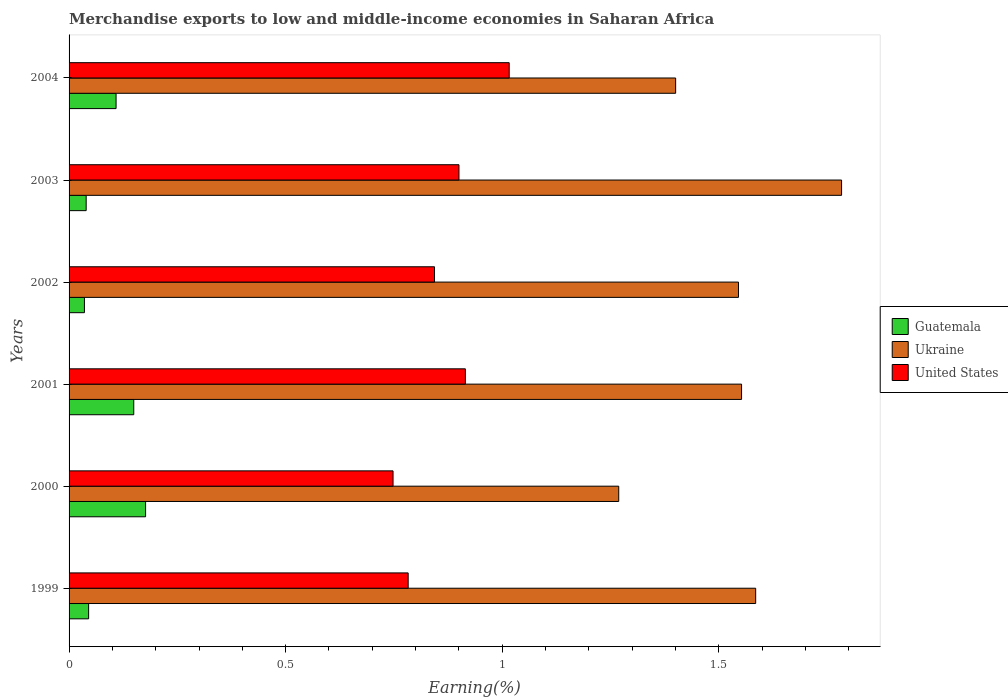How many bars are there on the 5th tick from the top?
Provide a short and direct response. 3. How many bars are there on the 3rd tick from the bottom?
Make the answer very short. 3. What is the label of the 6th group of bars from the top?
Your response must be concise. 1999. In how many cases, is the number of bars for a given year not equal to the number of legend labels?
Make the answer very short. 0. What is the percentage of amount earned from merchandise exports in United States in 2002?
Your response must be concise. 0.84. Across all years, what is the maximum percentage of amount earned from merchandise exports in United States?
Make the answer very short. 1.02. Across all years, what is the minimum percentage of amount earned from merchandise exports in United States?
Offer a very short reply. 0.75. In which year was the percentage of amount earned from merchandise exports in Guatemala maximum?
Ensure brevity in your answer.  2000. What is the total percentage of amount earned from merchandise exports in Guatemala in the graph?
Offer a very short reply. 0.55. What is the difference between the percentage of amount earned from merchandise exports in Ukraine in 2000 and that in 2001?
Offer a very short reply. -0.28. What is the difference between the percentage of amount earned from merchandise exports in Guatemala in 1999 and the percentage of amount earned from merchandise exports in United States in 2002?
Provide a short and direct response. -0.8. What is the average percentage of amount earned from merchandise exports in Ukraine per year?
Provide a succinct answer. 1.52. In the year 2004, what is the difference between the percentage of amount earned from merchandise exports in Guatemala and percentage of amount earned from merchandise exports in Ukraine?
Provide a short and direct response. -1.29. What is the ratio of the percentage of amount earned from merchandise exports in United States in 2002 to that in 2003?
Your answer should be compact. 0.94. Is the difference between the percentage of amount earned from merchandise exports in Guatemala in 2002 and 2003 greater than the difference between the percentage of amount earned from merchandise exports in Ukraine in 2002 and 2003?
Your response must be concise. Yes. What is the difference between the highest and the second highest percentage of amount earned from merchandise exports in Ukraine?
Offer a terse response. 0.2. What is the difference between the highest and the lowest percentage of amount earned from merchandise exports in Ukraine?
Provide a succinct answer. 0.51. In how many years, is the percentage of amount earned from merchandise exports in Ukraine greater than the average percentage of amount earned from merchandise exports in Ukraine taken over all years?
Provide a succinct answer. 4. Is the sum of the percentage of amount earned from merchandise exports in Ukraine in 2000 and 2001 greater than the maximum percentage of amount earned from merchandise exports in United States across all years?
Make the answer very short. Yes. What does the 2nd bar from the top in 2000 represents?
Your answer should be very brief. Ukraine. What does the 1st bar from the bottom in 1999 represents?
Give a very brief answer. Guatemala. Is it the case that in every year, the sum of the percentage of amount earned from merchandise exports in United States and percentage of amount earned from merchandise exports in Ukraine is greater than the percentage of amount earned from merchandise exports in Guatemala?
Make the answer very short. Yes. Does the graph contain grids?
Your answer should be compact. No. Where does the legend appear in the graph?
Offer a terse response. Center right. How are the legend labels stacked?
Offer a terse response. Vertical. What is the title of the graph?
Offer a terse response. Merchandise exports to low and middle-income economies in Saharan Africa. Does "East Asia (developing only)" appear as one of the legend labels in the graph?
Provide a succinct answer. No. What is the label or title of the X-axis?
Make the answer very short. Earning(%). What is the Earning(%) in Guatemala in 1999?
Your response must be concise. 0.05. What is the Earning(%) in Ukraine in 1999?
Ensure brevity in your answer.  1.59. What is the Earning(%) in United States in 1999?
Provide a succinct answer. 0.78. What is the Earning(%) in Guatemala in 2000?
Offer a terse response. 0.18. What is the Earning(%) of Ukraine in 2000?
Give a very brief answer. 1.27. What is the Earning(%) of United States in 2000?
Your answer should be very brief. 0.75. What is the Earning(%) in Guatemala in 2001?
Your answer should be very brief. 0.15. What is the Earning(%) in Ukraine in 2001?
Keep it short and to the point. 1.55. What is the Earning(%) in United States in 2001?
Your answer should be very brief. 0.91. What is the Earning(%) in Guatemala in 2002?
Give a very brief answer. 0.04. What is the Earning(%) in Ukraine in 2002?
Provide a succinct answer. 1.55. What is the Earning(%) of United States in 2002?
Make the answer very short. 0.84. What is the Earning(%) in Guatemala in 2003?
Your response must be concise. 0.04. What is the Earning(%) of Ukraine in 2003?
Your answer should be compact. 1.78. What is the Earning(%) in United States in 2003?
Give a very brief answer. 0.9. What is the Earning(%) of Guatemala in 2004?
Offer a very short reply. 0.11. What is the Earning(%) in Ukraine in 2004?
Provide a short and direct response. 1.4. What is the Earning(%) in United States in 2004?
Provide a succinct answer. 1.02. Across all years, what is the maximum Earning(%) in Guatemala?
Keep it short and to the point. 0.18. Across all years, what is the maximum Earning(%) in Ukraine?
Ensure brevity in your answer.  1.78. Across all years, what is the maximum Earning(%) in United States?
Your answer should be compact. 1.02. Across all years, what is the minimum Earning(%) in Guatemala?
Give a very brief answer. 0.04. Across all years, what is the minimum Earning(%) in Ukraine?
Your response must be concise. 1.27. Across all years, what is the minimum Earning(%) in United States?
Offer a very short reply. 0.75. What is the total Earning(%) in Guatemala in the graph?
Make the answer very short. 0.55. What is the total Earning(%) of Ukraine in the graph?
Keep it short and to the point. 9.14. What is the total Earning(%) in United States in the graph?
Offer a terse response. 5.21. What is the difference between the Earning(%) of Guatemala in 1999 and that in 2000?
Make the answer very short. -0.13. What is the difference between the Earning(%) in Ukraine in 1999 and that in 2000?
Keep it short and to the point. 0.32. What is the difference between the Earning(%) of United States in 1999 and that in 2000?
Provide a short and direct response. 0.03. What is the difference between the Earning(%) in Guatemala in 1999 and that in 2001?
Make the answer very short. -0.1. What is the difference between the Earning(%) of Ukraine in 1999 and that in 2001?
Offer a terse response. 0.03. What is the difference between the Earning(%) in United States in 1999 and that in 2001?
Provide a succinct answer. -0.13. What is the difference between the Earning(%) in Guatemala in 1999 and that in 2002?
Keep it short and to the point. 0.01. What is the difference between the Earning(%) of Ukraine in 1999 and that in 2002?
Provide a succinct answer. 0.04. What is the difference between the Earning(%) of United States in 1999 and that in 2002?
Provide a succinct answer. -0.06. What is the difference between the Earning(%) of Guatemala in 1999 and that in 2003?
Your answer should be very brief. 0.01. What is the difference between the Earning(%) of Ukraine in 1999 and that in 2003?
Provide a short and direct response. -0.2. What is the difference between the Earning(%) in United States in 1999 and that in 2003?
Ensure brevity in your answer.  -0.12. What is the difference between the Earning(%) of Guatemala in 1999 and that in 2004?
Offer a terse response. -0.06. What is the difference between the Earning(%) in Ukraine in 1999 and that in 2004?
Make the answer very short. 0.18. What is the difference between the Earning(%) of United States in 1999 and that in 2004?
Keep it short and to the point. -0.23. What is the difference between the Earning(%) in Guatemala in 2000 and that in 2001?
Ensure brevity in your answer.  0.03. What is the difference between the Earning(%) in Ukraine in 2000 and that in 2001?
Provide a succinct answer. -0.28. What is the difference between the Earning(%) in United States in 2000 and that in 2001?
Offer a terse response. -0.17. What is the difference between the Earning(%) in Guatemala in 2000 and that in 2002?
Make the answer very short. 0.14. What is the difference between the Earning(%) of Ukraine in 2000 and that in 2002?
Provide a short and direct response. -0.28. What is the difference between the Earning(%) in United States in 2000 and that in 2002?
Give a very brief answer. -0.1. What is the difference between the Earning(%) in Guatemala in 2000 and that in 2003?
Your response must be concise. 0.14. What is the difference between the Earning(%) in Ukraine in 2000 and that in 2003?
Your answer should be very brief. -0.51. What is the difference between the Earning(%) of United States in 2000 and that in 2003?
Offer a very short reply. -0.15. What is the difference between the Earning(%) of Guatemala in 2000 and that in 2004?
Provide a succinct answer. 0.07. What is the difference between the Earning(%) in Ukraine in 2000 and that in 2004?
Your answer should be very brief. -0.13. What is the difference between the Earning(%) in United States in 2000 and that in 2004?
Your answer should be compact. -0.27. What is the difference between the Earning(%) in Guatemala in 2001 and that in 2002?
Make the answer very short. 0.11. What is the difference between the Earning(%) of Ukraine in 2001 and that in 2002?
Offer a terse response. 0.01. What is the difference between the Earning(%) in United States in 2001 and that in 2002?
Your answer should be compact. 0.07. What is the difference between the Earning(%) of Guatemala in 2001 and that in 2003?
Keep it short and to the point. 0.11. What is the difference between the Earning(%) of Ukraine in 2001 and that in 2003?
Give a very brief answer. -0.23. What is the difference between the Earning(%) of United States in 2001 and that in 2003?
Provide a short and direct response. 0.01. What is the difference between the Earning(%) in Guatemala in 2001 and that in 2004?
Your answer should be very brief. 0.04. What is the difference between the Earning(%) in Ukraine in 2001 and that in 2004?
Provide a short and direct response. 0.15. What is the difference between the Earning(%) of United States in 2001 and that in 2004?
Provide a succinct answer. -0.1. What is the difference between the Earning(%) of Guatemala in 2002 and that in 2003?
Provide a short and direct response. -0. What is the difference between the Earning(%) of Ukraine in 2002 and that in 2003?
Provide a short and direct response. -0.24. What is the difference between the Earning(%) of United States in 2002 and that in 2003?
Ensure brevity in your answer.  -0.06. What is the difference between the Earning(%) in Guatemala in 2002 and that in 2004?
Provide a short and direct response. -0.07. What is the difference between the Earning(%) of Ukraine in 2002 and that in 2004?
Your answer should be compact. 0.15. What is the difference between the Earning(%) in United States in 2002 and that in 2004?
Your answer should be very brief. -0.17. What is the difference between the Earning(%) of Guatemala in 2003 and that in 2004?
Your response must be concise. -0.07. What is the difference between the Earning(%) of Ukraine in 2003 and that in 2004?
Offer a terse response. 0.38. What is the difference between the Earning(%) in United States in 2003 and that in 2004?
Ensure brevity in your answer.  -0.12. What is the difference between the Earning(%) of Guatemala in 1999 and the Earning(%) of Ukraine in 2000?
Your answer should be compact. -1.22. What is the difference between the Earning(%) of Guatemala in 1999 and the Earning(%) of United States in 2000?
Your answer should be compact. -0.7. What is the difference between the Earning(%) in Ukraine in 1999 and the Earning(%) in United States in 2000?
Give a very brief answer. 0.84. What is the difference between the Earning(%) in Guatemala in 1999 and the Earning(%) in Ukraine in 2001?
Ensure brevity in your answer.  -1.51. What is the difference between the Earning(%) of Guatemala in 1999 and the Earning(%) of United States in 2001?
Offer a very short reply. -0.87. What is the difference between the Earning(%) in Ukraine in 1999 and the Earning(%) in United States in 2001?
Keep it short and to the point. 0.67. What is the difference between the Earning(%) of Guatemala in 1999 and the Earning(%) of Ukraine in 2002?
Offer a terse response. -1.5. What is the difference between the Earning(%) in Guatemala in 1999 and the Earning(%) in United States in 2002?
Provide a succinct answer. -0.8. What is the difference between the Earning(%) in Ukraine in 1999 and the Earning(%) in United States in 2002?
Offer a terse response. 0.74. What is the difference between the Earning(%) in Guatemala in 1999 and the Earning(%) in Ukraine in 2003?
Your answer should be compact. -1.74. What is the difference between the Earning(%) of Guatemala in 1999 and the Earning(%) of United States in 2003?
Keep it short and to the point. -0.85. What is the difference between the Earning(%) in Ukraine in 1999 and the Earning(%) in United States in 2003?
Offer a terse response. 0.69. What is the difference between the Earning(%) of Guatemala in 1999 and the Earning(%) of Ukraine in 2004?
Ensure brevity in your answer.  -1.36. What is the difference between the Earning(%) of Guatemala in 1999 and the Earning(%) of United States in 2004?
Make the answer very short. -0.97. What is the difference between the Earning(%) in Ukraine in 1999 and the Earning(%) in United States in 2004?
Keep it short and to the point. 0.57. What is the difference between the Earning(%) of Guatemala in 2000 and the Earning(%) of Ukraine in 2001?
Ensure brevity in your answer.  -1.38. What is the difference between the Earning(%) in Guatemala in 2000 and the Earning(%) in United States in 2001?
Make the answer very short. -0.74. What is the difference between the Earning(%) of Ukraine in 2000 and the Earning(%) of United States in 2001?
Make the answer very short. 0.35. What is the difference between the Earning(%) in Guatemala in 2000 and the Earning(%) in Ukraine in 2002?
Offer a terse response. -1.37. What is the difference between the Earning(%) of Guatemala in 2000 and the Earning(%) of United States in 2002?
Provide a succinct answer. -0.67. What is the difference between the Earning(%) of Ukraine in 2000 and the Earning(%) of United States in 2002?
Give a very brief answer. 0.43. What is the difference between the Earning(%) of Guatemala in 2000 and the Earning(%) of Ukraine in 2003?
Give a very brief answer. -1.61. What is the difference between the Earning(%) in Guatemala in 2000 and the Earning(%) in United States in 2003?
Offer a terse response. -0.72. What is the difference between the Earning(%) in Ukraine in 2000 and the Earning(%) in United States in 2003?
Offer a very short reply. 0.37. What is the difference between the Earning(%) in Guatemala in 2000 and the Earning(%) in Ukraine in 2004?
Provide a succinct answer. -1.22. What is the difference between the Earning(%) in Guatemala in 2000 and the Earning(%) in United States in 2004?
Offer a very short reply. -0.84. What is the difference between the Earning(%) of Ukraine in 2000 and the Earning(%) of United States in 2004?
Offer a very short reply. 0.25. What is the difference between the Earning(%) of Guatemala in 2001 and the Earning(%) of Ukraine in 2002?
Make the answer very short. -1.4. What is the difference between the Earning(%) in Guatemala in 2001 and the Earning(%) in United States in 2002?
Give a very brief answer. -0.69. What is the difference between the Earning(%) of Ukraine in 2001 and the Earning(%) of United States in 2002?
Your response must be concise. 0.71. What is the difference between the Earning(%) in Guatemala in 2001 and the Earning(%) in Ukraine in 2003?
Your answer should be compact. -1.63. What is the difference between the Earning(%) in Guatemala in 2001 and the Earning(%) in United States in 2003?
Make the answer very short. -0.75. What is the difference between the Earning(%) of Ukraine in 2001 and the Earning(%) of United States in 2003?
Ensure brevity in your answer.  0.65. What is the difference between the Earning(%) in Guatemala in 2001 and the Earning(%) in Ukraine in 2004?
Provide a succinct answer. -1.25. What is the difference between the Earning(%) in Guatemala in 2001 and the Earning(%) in United States in 2004?
Keep it short and to the point. -0.87. What is the difference between the Earning(%) of Ukraine in 2001 and the Earning(%) of United States in 2004?
Provide a short and direct response. 0.54. What is the difference between the Earning(%) of Guatemala in 2002 and the Earning(%) of Ukraine in 2003?
Give a very brief answer. -1.75. What is the difference between the Earning(%) in Guatemala in 2002 and the Earning(%) in United States in 2003?
Provide a succinct answer. -0.86. What is the difference between the Earning(%) in Ukraine in 2002 and the Earning(%) in United States in 2003?
Your answer should be compact. 0.65. What is the difference between the Earning(%) of Guatemala in 2002 and the Earning(%) of Ukraine in 2004?
Provide a succinct answer. -1.36. What is the difference between the Earning(%) in Guatemala in 2002 and the Earning(%) in United States in 2004?
Give a very brief answer. -0.98. What is the difference between the Earning(%) of Ukraine in 2002 and the Earning(%) of United States in 2004?
Give a very brief answer. 0.53. What is the difference between the Earning(%) of Guatemala in 2003 and the Earning(%) of Ukraine in 2004?
Your response must be concise. -1.36. What is the difference between the Earning(%) of Guatemala in 2003 and the Earning(%) of United States in 2004?
Keep it short and to the point. -0.98. What is the difference between the Earning(%) of Ukraine in 2003 and the Earning(%) of United States in 2004?
Provide a short and direct response. 0.77. What is the average Earning(%) of Guatemala per year?
Offer a terse response. 0.09. What is the average Earning(%) of Ukraine per year?
Ensure brevity in your answer.  1.52. What is the average Earning(%) of United States per year?
Ensure brevity in your answer.  0.87. In the year 1999, what is the difference between the Earning(%) in Guatemala and Earning(%) in Ukraine?
Your response must be concise. -1.54. In the year 1999, what is the difference between the Earning(%) of Guatemala and Earning(%) of United States?
Give a very brief answer. -0.74. In the year 1999, what is the difference between the Earning(%) of Ukraine and Earning(%) of United States?
Make the answer very short. 0.8. In the year 2000, what is the difference between the Earning(%) in Guatemala and Earning(%) in Ukraine?
Give a very brief answer. -1.09. In the year 2000, what is the difference between the Earning(%) in Guatemala and Earning(%) in United States?
Your answer should be compact. -0.57. In the year 2000, what is the difference between the Earning(%) of Ukraine and Earning(%) of United States?
Offer a terse response. 0.52. In the year 2001, what is the difference between the Earning(%) of Guatemala and Earning(%) of Ukraine?
Your answer should be compact. -1.4. In the year 2001, what is the difference between the Earning(%) in Guatemala and Earning(%) in United States?
Give a very brief answer. -0.77. In the year 2001, what is the difference between the Earning(%) of Ukraine and Earning(%) of United States?
Ensure brevity in your answer.  0.64. In the year 2002, what is the difference between the Earning(%) of Guatemala and Earning(%) of Ukraine?
Provide a short and direct response. -1.51. In the year 2002, what is the difference between the Earning(%) in Guatemala and Earning(%) in United States?
Offer a very short reply. -0.81. In the year 2002, what is the difference between the Earning(%) in Ukraine and Earning(%) in United States?
Keep it short and to the point. 0.7. In the year 2003, what is the difference between the Earning(%) of Guatemala and Earning(%) of Ukraine?
Provide a short and direct response. -1.74. In the year 2003, what is the difference between the Earning(%) of Guatemala and Earning(%) of United States?
Provide a short and direct response. -0.86. In the year 2003, what is the difference between the Earning(%) in Ukraine and Earning(%) in United States?
Your answer should be very brief. 0.88. In the year 2004, what is the difference between the Earning(%) in Guatemala and Earning(%) in Ukraine?
Give a very brief answer. -1.29. In the year 2004, what is the difference between the Earning(%) in Guatemala and Earning(%) in United States?
Offer a terse response. -0.91. In the year 2004, what is the difference between the Earning(%) in Ukraine and Earning(%) in United States?
Give a very brief answer. 0.38. What is the ratio of the Earning(%) in Guatemala in 1999 to that in 2000?
Provide a short and direct response. 0.26. What is the ratio of the Earning(%) of Ukraine in 1999 to that in 2000?
Make the answer very short. 1.25. What is the ratio of the Earning(%) in United States in 1999 to that in 2000?
Your answer should be compact. 1.05. What is the ratio of the Earning(%) in Guatemala in 1999 to that in 2001?
Make the answer very short. 0.3. What is the ratio of the Earning(%) in United States in 1999 to that in 2001?
Provide a short and direct response. 0.86. What is the ratio of the Earning(%) of Guatemala in 1999 to that in 2002?
Offer a terse response. 1.27. What is the ratio of the Earning(%) of Ukraine in 1999 to that in 2002?
Offer a terse response. 1.03. What is the ratio of the Earning(%) of United States in 1999 to that in 2002?
Keep it short and to the point. 0.93. What is the ratio of the Earning(%) of Guatemala in 1999 to that in 2003?
Offer a very short reply. 1.14. What is the ratio of the Earning(%) of Ukraine in 1999 to that in 2003?
Give a very brief answer. 0.89. What is the ratio of the Earning(%) in United States in 1999 to that in 2003?
Provide a succinct answer. 0.87. What is the ratio of the Earning(%) in Guatemala in 1999 to that in 2004?
Keep it short and to the point. 0.42. What is the ratio of the Earning(%) in Ukraine in 1999 to that in 2004?
Keep it short and to the point. 1.13. What is the ratio of the Earning(%) of United States in 1999 to that in 2004?
Ensure brevity in your answer.  0.77. What is the ratio of the Earning(%) of Guatemala in 2000 to that in 2001?
Offer a terse response. 1.18. What is the ratio of the Earning(%) of Ukraine in 2000 to that in 2001?
Provide a short and direct response. 0.82. What is the ratio of the Earning(%) in United States in 2000 to that in 2001?
Offer a very short reply. 0.82. What is the ratio of the Earning(%) of Guatemala in 2000 to that in 2002?
Give a very brief answer. 4.98. What is the ratio of the Earning(%) in Ukraine in 2000 to that in 2002?
Your answer should be very brief. 0.82. What is the ratio of the Earning(%) of United States in 2000 to that in 2002?
Your response must be concise. 0.89. What is the ratio of the Earning(%) of Guatemala in 2000 to that in 2003?
Your answer should be compact. 4.47. What is the ratio of the Earning(%) of Ukraine in 2000 to that in 2003?
Offer a terse response. 0.71. What is the ratio of the Earning(%) of United States in 2000 to that in 2003?
Offer a terse response. 0.83. What is the ratio of the Earning(%) in Guatemala in 2000 to that in 2004?
Ensure brevity in your answer.  1.63. What is the ratio of the Earning(%) of Ukraine in 2000 to that in 2004?
Offer a terse response. 0.91. What is the ratio of the Earning(%) of United States in 2000 to that in 2004?
Provide a succinct answer. 0.74. What is the ratio of the Earning(%) in Guatemala in 2001 to that in 2002?
Offer a terse response. 4.21. What is the ratio of the Earning(%) in Ukraine in 2001 to that in 2002?
Make the answer very short. 1. What is the ratio of the Earning(%) in United States in 2001 to that in 2002?
Give a very brief answer. 1.08. What is the ratio of the Earning(%) in Guatemala in 2001 to that in 2003?
Your answer should be compact. 3.78. What is the ratio of the Earning(%) in Ukraine in 2001 to that in 2003?
Give a very brief answer. 0.87. What is the ratio of the Earning(%) of United States in 2001 to that in 2003?
Make the answer very short. 1.02. What is the ratio of the Earning(%) in Guatemala in 2001 to that in 2004?
Your response must be concise. 1.38. What is the ratio of the Earning(%) in Ukraine in 2001 to that in 2004?
Make the answer very short. 1.11. What is the ratio of the Earning(%) of United States in 2001 to that in 2004?
Your response must be concise. 0.9. What is the ratio of the Earning(%) in Guatemala in 2002 to that in 2003?
Make the answer very short. 0.9. What is the ratio of the Earning(%) of Ukraine in 2002 to that in 2003?
Offer a very short reply. 0.87. What is the ratio of the Earning(%) in United States in 2002 to that in 2003?
Your answer should be compact. 0.94. What is the ratio of the Earning(%) of Guatemala in 2002 to that in 2004?
Provide a succinct answer. 0.33. What is the ratio of the Earning(%) of Ukraine in 2002 to that in 2004?
Give a very brief answer. 1.1. What is the ratio of the Earning(%) of United States in 2002 to that in 2004?
Offer a very short reply. 0.83. What is the ratio of the Earning(%) of Guatemala in 2003 to that in 2004?
Offer a very short reply. 0.36. What is the ratio of the Earning(%) of Ukraine in 2003 to that in 2004?
Provide a succinct answer. 1.27. What is the ratio of the Earning(%) of United States in 2003 to that in 2004?
Your response must be concise. 0.89. What is the difference between the highest and the second highest Earning(%) of Guatemala?
Provide a succinct answer. 0.03. What is the difference between the highest and the second highest Earning(%) of Ukraine?
Offer a very short reply. 0.2. What is the difference between the highest and the second highest Earning(%) in United States?
Your answer should be very brief. 0.1. What is the difference between the highest and the lowest Earning(%) in Guatemala?
Keep it short and to the point. 0.14. What is the difference between the highest and the lowest Earning(%) in Ukraine?
Offer a very short reply. 0.51. What is the difference between the highest and the lowest Earning(%) in United States?
Provide a short and direct response. 0.27. 